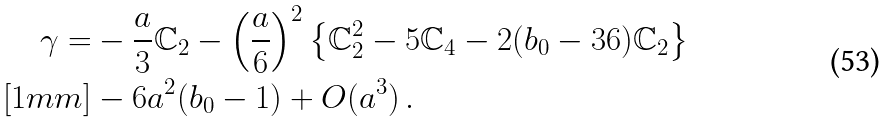<formula> <loc_0><loc_0><loc_500><loc_500>\gamma = & - \frac { a } { 3 } \mathbb { C } _ { 2 } - \left ( \frac { a } { 6 } \right ) ^ { 2 } \left \{ \mathbb { C } _ { 2 } ^ { 2 } - { 5 } \mathbb { C } _ { 4 } - 2 ( b _ { 0 } - 3 6 ) \mathbb { C } _ { 2 } \right \} \\ [ 1 m m ] & - 6 a ^ { 2 } ( b _ { 0 } - 1 ) + O ( a ^ { 3 } ) \, .</formula> 